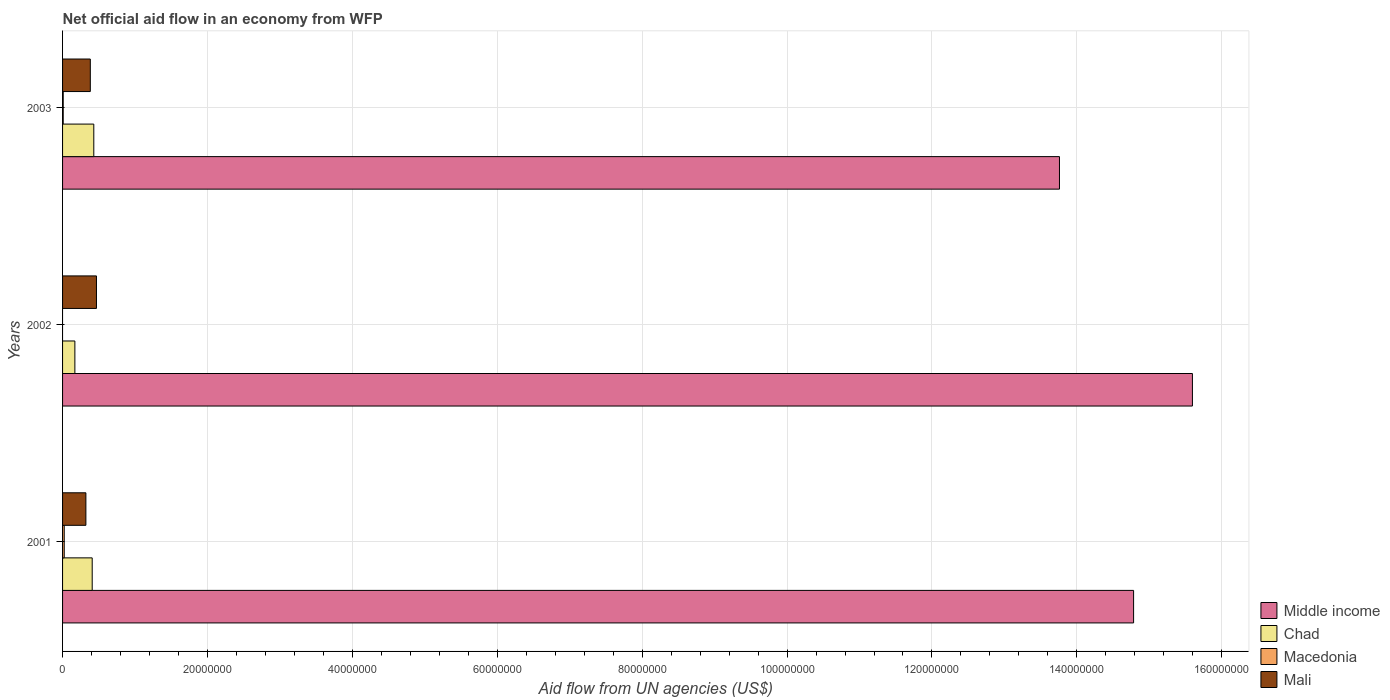How many groups of bars are there?
Your answer should be very brief. 3. Are the number of bars on each tick of the Y-axis equal?
Make the answer very short. No. How many bars are there on the 2nd tick from the top?
Offer a terse response. 3. How many bars are there on the 3rd tick from the bottom?
Offer a very short reply. 4. In how many cases, is the number of bars for a given year not equal to the number of legend labels?
Offer a terse response. 1. What is the net official aid flow in Middle income in 2003?
Keep it short and to the point. 1.38e+08. Across all years, what is the maximum net official aid flow in Macedonia?
Offer a very short reply. 2.30e+05. Across all years, what is the minimum net official aid flow in Mali?
Give a very brief answer. 3.22e+06. In which year was the net official aid flow in Chad maximum?
Ensure brevity in your answer.  2003. What is the total net official aid flow in Middle income in the graph?
Provide a short and direct response. 4.41e+08. What is the difference between the net official aid flow in Mali in 2001 and that in 2002?
Make the answer very short. -1.46e+06. What is the difference between the net official aid flow in Mali in 2003 and the net official aid flow in Chad in 2002?
Give a very brief answer. 2.13e+06. What is the average net official aid flow in Chad per year?
Make the answer very short. 3.37e+06. In the year 2003, what is the difference between the net official aid flow in Middle income and net official aid flow in Chad?
Make the answer very short. 1.33e+08. What is the ratio of the net official aid flow in Chad in 2001 to that in 2002?
Provide a short and direct response. 2.41. Is the net official aid flow in Middle income in 2001 less than that in 2003?
Give a very brief answer. No. What is the difference between the highest and the second highest net official aid flow in Chad?
Ensure brevity in your answer.  2.20e+05. What is the difference between the highest and the lowest net official aid flow in Mali?
Provide a short and direct response. 1.46e+06. In how many years, is the net official aid flow in Chad greater than the average net official aid flow in Chad taken over all years?
Your response must be concise. 2. Is the sum of the net official aid flow in Macedonia in 2001 and 2003 greater than the maximum net official aid flow in Mali across all years?
Your answer should be very brief. No. Is it the case that in every year, the sum of the net official aid flow in Chad and net official aid flow in Macedonia is greater than the sum of net official aid flow in Middle income and net official aid flow in Mali?
Offer a very short reply. No. Is it the case that in every year, the sum of the net official aid flow in Chad and net official aid flow in Mali is greater than the net official aid flow in Middle income?
Provide a succinct answer. No. How many bars are there?
Your answer should be compact. 11. Are all the bars in the graph horizontal?
Provide a succinct answer. Yes. What is the difference between two consecutive major ticks on the X-axis?
Give a very brief answer. 2.00e+07. Are the values on the major ticks of X-axis written in scientific E-notation?
Offer a very short reply. No. Does the graph contain any zero values?
Provide a short and direct response. Yes. Does the graph contain grids?
Your answer should be very brief. Yes. Where does the legend appear in the graph?
Offer a very short reply. Bottom right. How many legend labels are there?
Your response must be concise. 4. What is the title of the graph?
Offer a terse response. Net official aid flow in an economy from WFP. What is the label or title of the X-axis?
Your response must be concise. Aid flow from UN agencies (US$). What is the label or title of the Y-axis?
Give a very brief answer. Years. What is the Aid flow from UN agencies (US$) of Middle income in 2001?
Make the answer very short. 1.48e+08. What is the Aid flow from UN agencies (US$) of Chad in 2001?
Offer a very short reply. 4.09e+06. What is the Aid flow from UN agencies (US$) in Mali in 2001?
Ensure brevity in your answer.  3.22e+06. What is the Aid flow from UN agencies (US$) in Middle income in 2002?
Your response must be concise. 1.56e+08. What is the Aid flow from UN agencies (US$) of Chad in 2002?
Make the answer very short. 1.70e+06. What is the Aid flow from UN agencies (US$) in Mali in 2002?
Your answer should be very brief. 4.68e+06. What is the Aid flow from UN agencies (US$) in Middle income in 2003?
Give a very brief answer. 1.38e+08. What is the Aid flow from UN agencies (US$) in Chad in 2003?
Your response must be concise. 4.31e+06. What is the Aid flow from UN agencies (US$) of Macedonia in 2003?
Offer a terse response. 9.00e+04. What is the Aid flow from UN agencies (US$) of Mali in 2003?
Ensure brevity in your answer.  3.83e+06. Across all years, what is the maximum Aid flow from UN agencies (US$) in Middle income?
Provide a succinct answer. 1.56e+08. Across all years, what is the maximum Aid flow from UN agencies (US$) of Chad?
Your answer should be compact. 4.31e+06. Across all years, what is the maximum Aid flow from UN agencies (US$) in Mali?
Offer a very short reply. 4.68e+06. Across all years, what is the minimum Aid flow from UN agencies (US$) of Middle income?
Make the answer very short. 1.38e+08. Across all years, what is the minimum Aid flow from UN agencies (US$) in Chad?
Your response must be concise. 1.70e+06. Across all years, what is the minimum Aid flow from UN agencies (US$) in Mali?
Make the answer very short. 3.22e+06. What is the total Aid flow from UN agencies (US$) of Middle income in the graph?
Give a very brief answer. 4.41e+08. What is the total Aid flow from UN agencies (US$) in Chad in the graph?
Offer a very short reply. 1.01e+07. What is the total Aid flow from UN agencies (US$) of Macedonia in the graph?
Ensure brevity in your answer.  3.20e+05. What is the total Aid flow from UN agencies (US$) in Mali in the graph?
Your answer should be compact. 1.17e+07. What is the difference between the Aid flow from UN agencies (US$) of Middle income in 2001 and that in 2002?
Make the answer very short. -8.12e+06. What is the difference between the Aid flow from UN agencies (US$) of Chad in 2001 and that in 2002?
Provide a short and direct response. 2.39e+06. What is the difference between the Aid flow from UN agencies (US$) of Mali in 2001 and that in 2002?
Your answer should be compact. -1.46e+06. What is the difference between the Aid flow from UN agencies (US$) of Middle income in 2001 and that in 2003?
Make the answer very short. 1.02e+07. What is the difference between the Aid flow from UN agencies (US$) of Mali in 2001 and that in 2003?
Your answer should be compact. -6.10e+05. What is the difference between the Aid flow from UN agencies (US$) in Middle income in 2002 and that in 2003?
Provide a succinct answer. 1.84e+07. What is the difference between the Aid flow from UN agencies (US$) in Chad in 2002 and that in 2003?
Make the answer very short. -2.61e+06. What is the difference between the Aid flow from UN agencies (US$) of Mali in 2002 and that in 2003?
Make the answer very short. 8.50e+05. What is the difference between the Aid flow from UN agencies (US$) of Middle income in 2001 and the Aid flow from UN agencies (US$) of Chad in 2002?
Ensure brevity in your answer.  1.46e+08. What is the difference between the Aid flow from UN agencies (US$) of Middle income in 2001 and the Aid flow from UN agencies (US$) of Mali in 2002?
Your response must be concise. 1.43e+08. What is the difference between the Aid flow from UN agencies (US$) of Chad in 2001 and the Aid flow from UN agencies (US$) of Mali in 2002?
Make the answer very short. -5.90e+05. What is the difference between the Aid flow from UN agencies (US$) in Macedonia in 2001 and the Aid flow from UN agencies (US$) in Mali in 2002?
Give a very brief answer. -4.45e+06. What is the difference between the Aid flow from UN agencies (US$) in Middle income in 2001 and the Aid flow from UN agencies (US$) in Chad in 2003?
Keep it short and to the point. 1.44e+08. What is the difference between the Aid flow from UN agencies (US$) in Middle income in 2001 and the Aid flow from UN agencies (US$) in Macedonia in 2003?
Offer a very short reply. 1.48e+08. What is the difference between the Aid flow from UN agencies (US$) of Middle income in 2001 and the Aid flow from UN agencies (US$) of Mali in 2003?
Make the answer very short. 1.44e+08. What is the difference between the Aid flow from UN agencies (US$) in Macedonia in 2001 and the Aid flow from UN agencies (US$) in Mali in 2003?
Offer a terse response. -3.60e+06. What is the difference between the Aid flow from UN agencies (US$) in Middle income in 2002 and the Aid flow from UN agencies (US$) in Chad in 2003?
Offer a terse response. 1.52e+08. What is the difference between the Aid flow from UN agencies (US$) in Middle income in 2002 and the Aid flow from UN agencies (US$) in Macedonia in 2003?
Your response must be concise. 1.56e+08. What is the difference between the Aid flow from UN agencies (US$) in Middle income in 2002 and the Aid flow from UN agencies (US$) in Mali in 2003?
Make the answer very short. 1.52e+08. What is the difference between the Aid flow from UN agencies (US$) in Chad in 2002 and the Aid flow from UN agencies (US$) in Macedonia in 2003?
Your answer should be very brief. 1.61e+06. What is the difference between the Aid flow from UN agencies (US$) of Chad in 2002 and the Aid flow from UN agencies (US$) of Mali in 2003?
Provide a succinct answer. -2.13e+06. What is the average Aid flow from UN agencies (US$) in Middle income per year?
Your answer should be compact. 1.47e+08. What is the average Aid flow from UN agencies (US$) in Chad per year?
Keep it short and to the point. 3.37e+06. What is the average Aid flow from UN agencies (US$) of Macedonia per year?
Your response must be concise. 1.07e+05. What is the average Aid flow from UN agencies (US$) in Mali per year?
Provide a succinct answer. 3.91e+06. In the year 2001, what is the difference between the Aid flow from UN agencies (US$) in Middle income and Aid flow from UN agencies (US$) in Chad?
Make the answer very short. 1.44e+08. In the year 2001, what is the difference between the Aid flow from UN agencies (US$) in Middle income and Aid flow from UN agencies (US$) in Macedonia?
Keep it short and to the point. 1.48e+08. In the year 2001, what is the difference between the Aid flow from UN agencies (US$) in Middle income and Aid flow from UN agencies (US$) in Mali?
Your answer should be very brief. 1.45e+08. In the year 2001, what is the difference between the Aid flow from UN agencies (US$) of Chad and Aid flow from UN agencies (US$) of Macedonia?
Provide a short and direct response. 3.86e+06. In the year 2001, what is the difference between the Aid flow from UN agencies (US$) in Chad and Aid flow from UN agencies (US$) in Mali?
Provide a succinct answer. 8.70e+05. In the year 2001, what is the difference between the Aid flow from UN agencies (US$) in Macedonia and Aid flow from UN agencies (US$) in Mali?
Provide a succinct answer. -2.99e+06. In the year 2002, what is the difference between the Aid flow from UN agencies (US$) of Middle income and Aid flow from UN agencies (US$) of Chad?
Provide a succinct answer. 1.54e+08. In the year 2002, what is the difference between the Aid flow from UN agencies (US$) in Middle income and Aid flow from UN agencies (US$) in Mali?
Make the answer very short. 1.51e+08. In the year 2002, what is the difference between the Aid flow from UN agencies (US$) of Chad and Aid flow from UN agencies (US$) of Mali?
Provide a short and direct response. -2.98e+06. In the year 2003, what is the difference between the Aid flow from UN agencies (US$) of Middle income and Aid flow from UN agencies (US$) of Chad?
Your answer should be compact. 1.33e+08. In the year 2003, what is the difference between the Aid flow from UN agencies (US$) in Middle income and Aid flow from UN agencies (US$) in Macedonia?
Offer a terse response. 1.38e+08. In the year 2003, what is the difference between the Aid flow from UN agencies (US$) of Middle income and Aid flow from UN agencies (US$) of Mali?
Offer a very short reply. 1.34e+08. In the year 2003, what is the difference between the Aid flow from UN agencies (US$) in Chad and Aid flow from UN agencies (US$) in Macedonia?
Your answer should be compact. 4.22e+06. In the year 2003, what is the difference between the Aid flow from UN agencies (US$) of Macedonia and Aid flow from UN agencies (US$) of Mali?
Ensure brevity in your answer.  -3.74e+06. What is the ratio of the Aid flow from UN agencies (US$) of Middle income in 2001 to that in 2002?
Offer a terse response. 0.95. What is the ratio of the Aid flow from UN agencies (US$) of Chad in 2001 to that in 2002?
Your answer should be very brief. 2.41. What is the ratio of the Aid flow from UN agencies (US$) in Mali in 2001 to that in 2002?
Keep it short and to the point. 0.69. What is the ratio of the Aid flow from UN agencies (US$) of Middle income in 2001 to that in 2003?
Ensure brevity in your answer.  1.07. What is the ratio of the Aid flow from UN agencies (US$) of Chad in 2001 to that in 2003?
Keep it short and to the point. 0.95. What is the ratio of the Aid flow from UN agencies (US$) of Macedonia in 2001 to that in 2003?
Ensure brevity in your answer.  2.56. What is the ratio of the Aid flow from UN agencies (US$) of Mali in 2001 to that in 2003?
Your response must be concise. 0.84. What is the ratio of the Aid flow from UN agencies (US$) in Middle income in 2002 to that in 2003?
Give a very brief answer. 1.13. What is the ratio of the Aid flow from UN agencies (US$) in Chad in 2002 to that in 2003?
Make the answer very short. 0.39. What is the ratio of the Aid flow from UN agencies (US$) of Mali in 2002 to that in 2003?
Keep it short and to the point. 1.22. What is the difference between the highest and the second highest Aid flow from UN agencies (US$) of Middle income?
Your answer should be very brief. 8.12e+06. What is the difference between the highest and the second highest Aid flow from UN agencies (US$) in Mali?
Your answer should be very brief. 8.50e+05. What is the difference between the highest and the lowest Aid flow from UN agencies (US$) in Middle income?
Your response must be concise. 1.84e+07. What is the difference between the highest and the lowest Aid flow from UN agencies (US$) in Chad?
Offer a terse response. 2.61e+06. What is the difference between the highest and the lowest Aid flow from UN agencies (US$) in Mali?
Ensure brevity in your answer.  1.46e+06. 